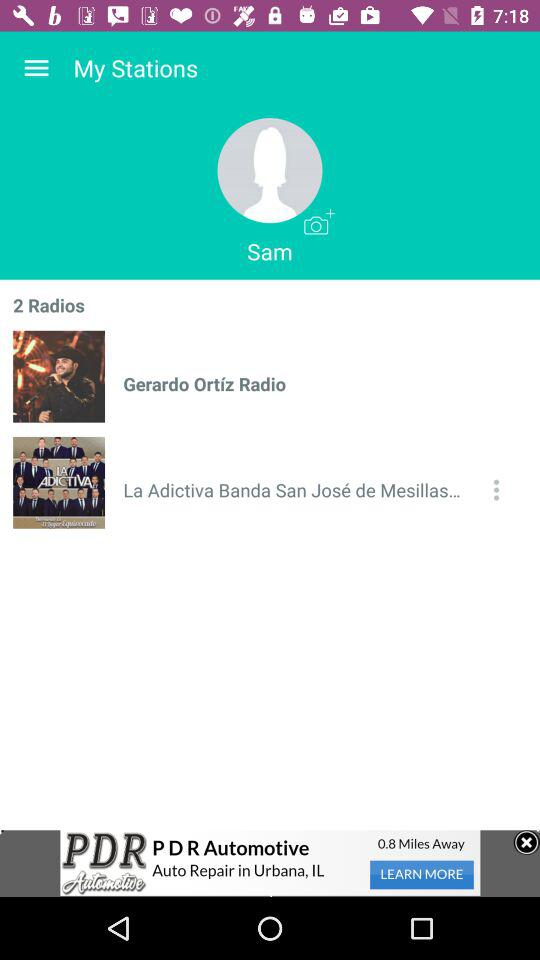How many radio stations are there? There are 2 radio stations. 